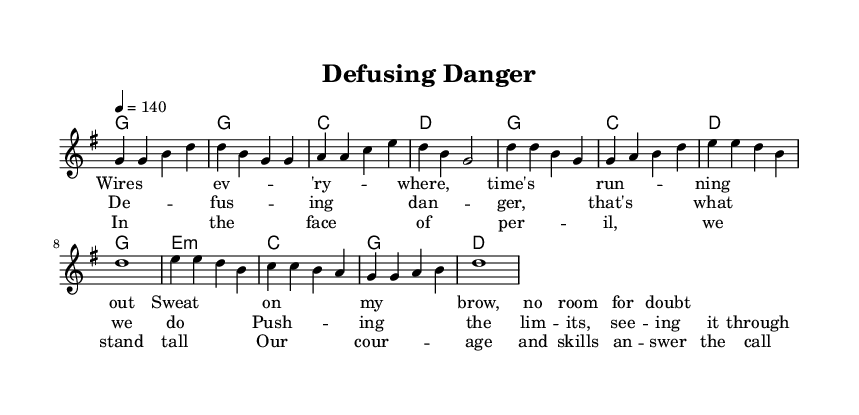What is the key signature of this music? The key signature is G major, which has one sharp (F#). This can be determined by looking at the part of the sheet music that indicates the sharps or flats; there is one sharp reflecting the G major key.
Answer: G major What is the time signature of this music? The time signature is 4/4, which can be seen near the beginning of the score. It indicates that there are four beats in each measure and the quarter note gets one beat.
Answer: 4/4 What is the tempo marking for this piece? The tempo marking is 140 beats per minute, indicated as "4 = 140" at the start of the score. This means there are 140 quarter note beats in a minute.
Answer: 140 What is the first lyric of the verse? The first lyric of the verse is "Wires every where," which can be found at the beginning of the lyric notation corresponding to the melody line.
Answer: Wires every where How many measures are in the chorus? There are four measures in the chorus, which can be counted by looking at the chord progression and corresponding lyrics during the chorus section. Each line of the lyrics corresponds to one measure.
Answer: 4 What is the chord used in the bridge section? The chord used in the bridge section is E minor, as indicated in the chord mode section of the score for the bridge. This chord is featured prominently in that section.
Answer: E minor What theme does this song convey? The theme conveyed in this song is "overcoming challenges," as reflected in the lyrics about defusing danger and pushing limits. The lyrics and overall message highlight bravery in difficult occupations.
Answer: Overcoming challenges 